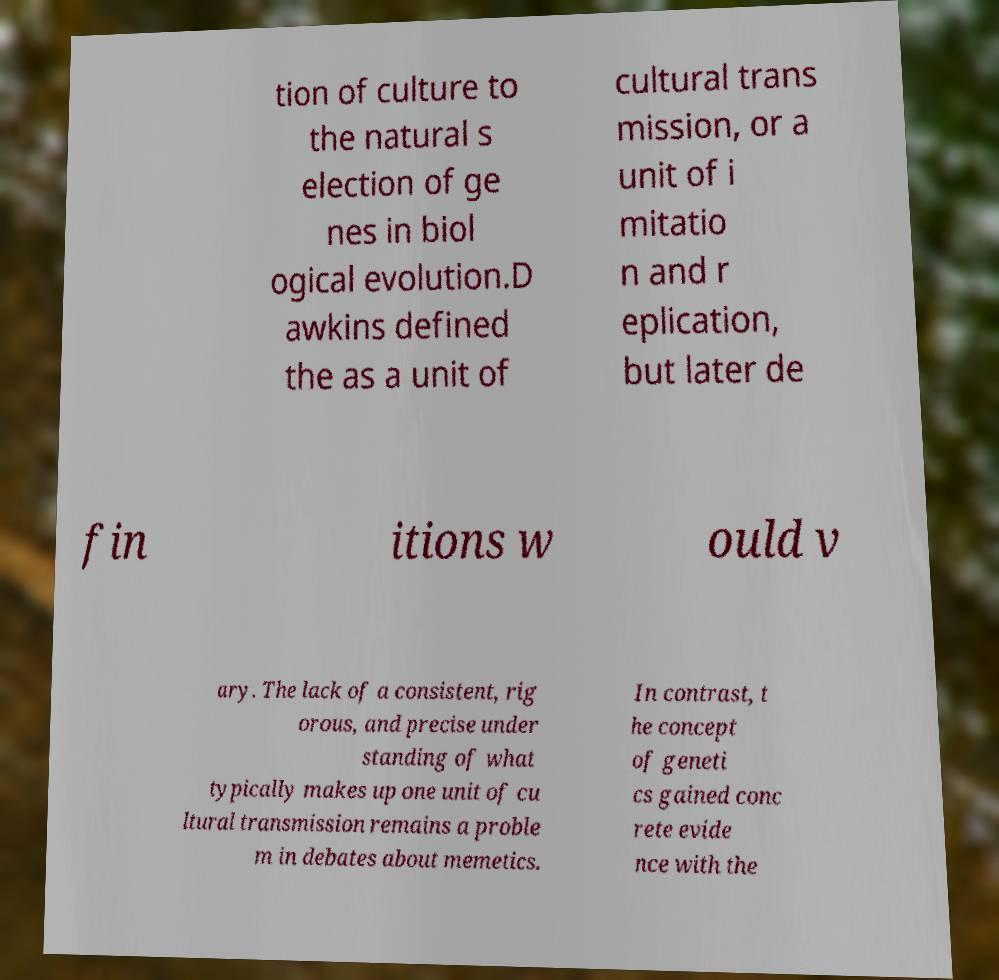There's text embedded in this image that I need extracted. Can you transcribe it verbatim? tion of culture to the natural s election of ge nes in biol ogical evolution.D awkins defined the as a unit of cultural trans mission, or a unit of i mitatio n and r eplication, but later de fin itions w ould v ary. The lack of a consistent, rig orous, and precise under standing of what typically makes up one unit of cu ltural transmission remains a proble m in debates about memetics. In contrast, t he concept of geneti cs gained conc rete evide nce with the 